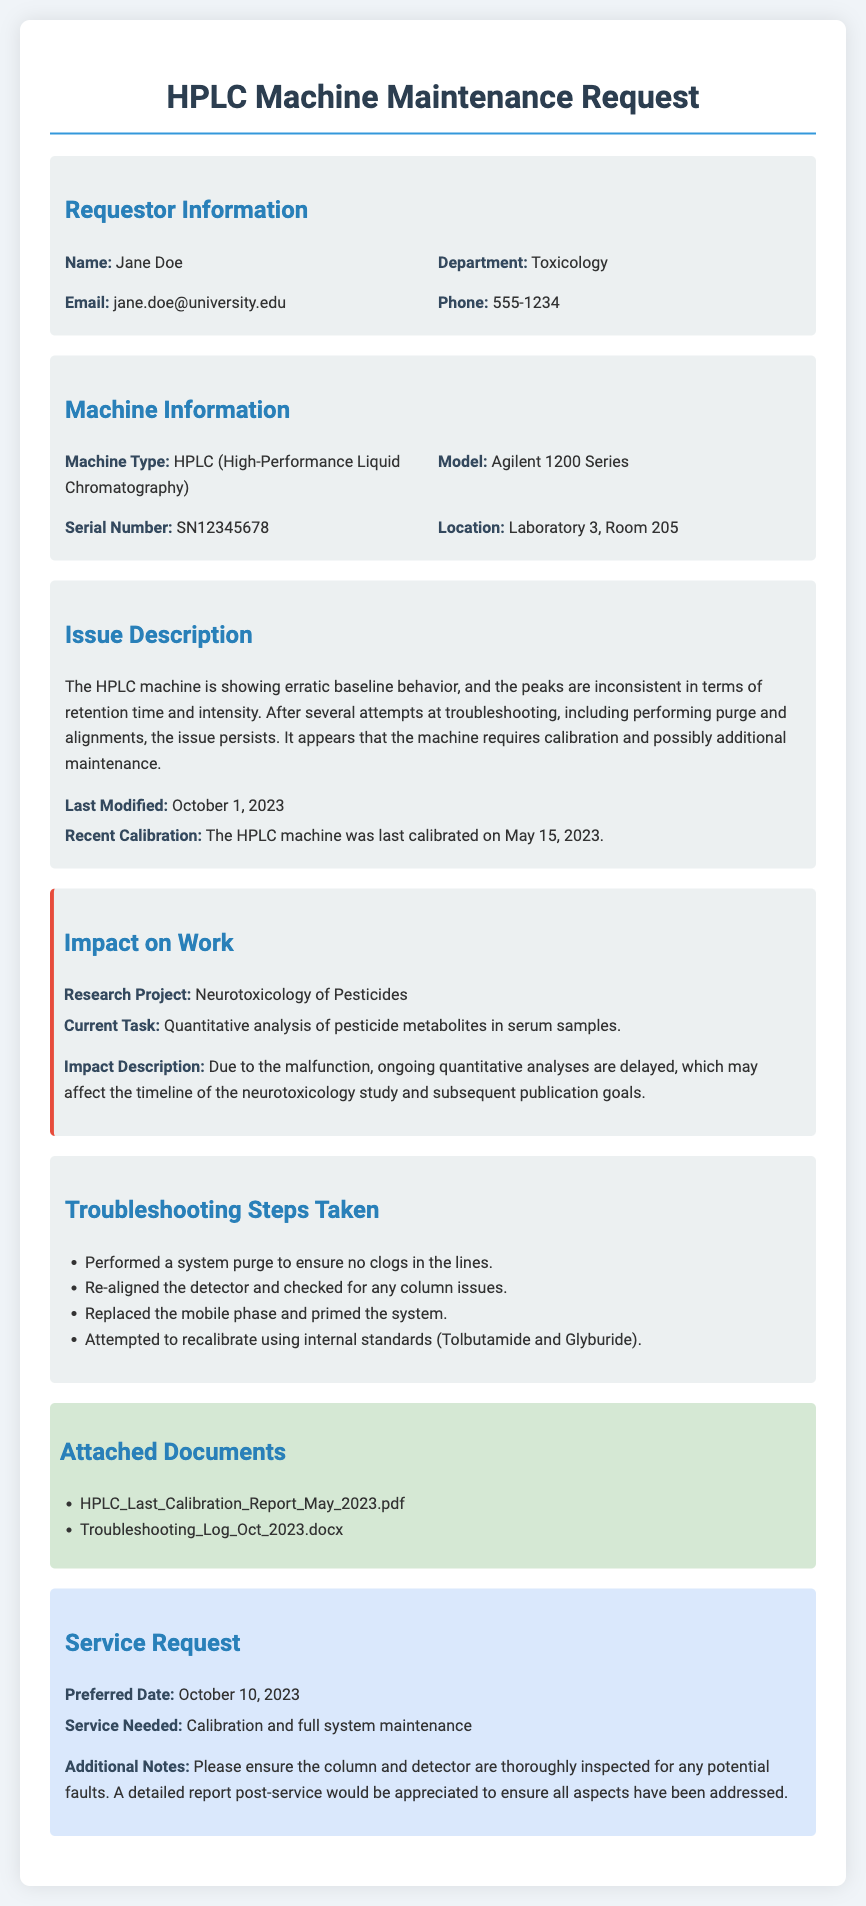What is the name of the requestor? The requestor's name is explicitly mentioned in the document as Jane Doe.
Answer: Jane Doe What is the model of the HPLC machine? The model of the HPLC machine is stated as Agilent 1200 Series in the machine information section.
Answer: Agilent 1200 Series What was the issue described with the HPLC machine? The issue is summarized as erratic baseline behavior and inconsistent peaks in retention time and intensity, indicating a need for calibration.
Answer: Erratic baseline behavior When was the last calibration conducted? The last calibration date is provided in the document, which is May 15, 2023.
Answer: May 15, 2023 What is the current research project mentioned? The current research project being affected is stated as Neurotoxicology of Pesticides.
Answer: Neurotoxicology of Pesticides How many troubleshooting steps were taken? The document lists four troubleshooting steps taken to address the HPLC machine issues.
Answer: Four What service is needed for the HPLC machine? The service required for the HPLC machine is clearly stated as Calibration and full system maintenance.
Answer: Calibration and full system maintenance What is the preferred date for the service request? The preferred date for servicing is mentioned as October 10, 2023.
Answer: October 10, 2023 What is the phone number of the requestor? The requestor's phone number is directly listed in the document as 555-1234.
Answer: 555-1234 